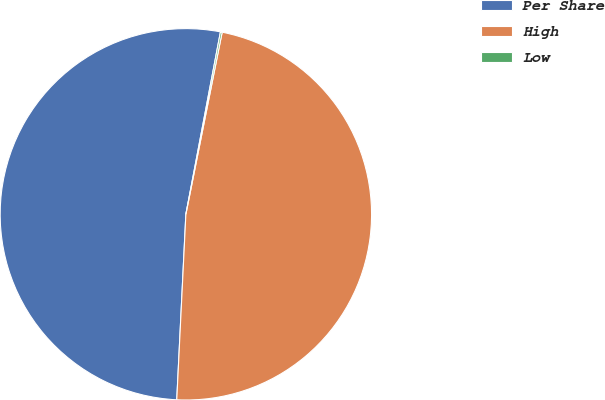Convert chart to OTSL. <chart><loc_0><loc_0><loc_500><loc_500><pie_chart><fcel>Per Share<fcel>High<fcel>Low<nl><fcel>52.2%<fcel>47.65%<fcel>0.15%<nl></chart> 